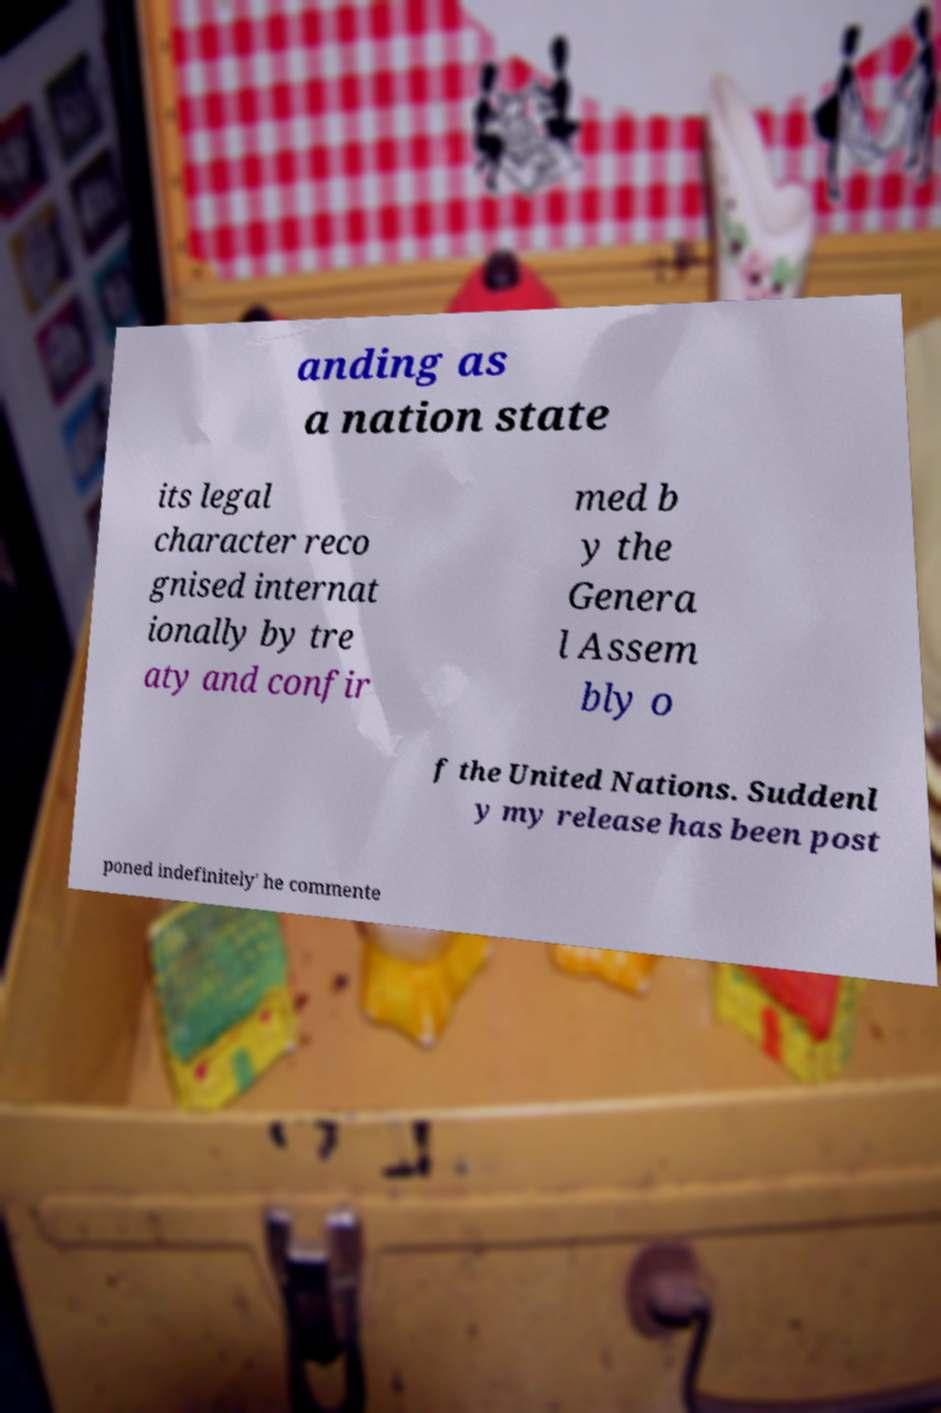Could you extract and type out the text from this image? anding as a nation state its legal character reco gnised internat ionally by tre aty and confir med b y the Genera l Assem bly o f the United Nations. Suddenl y my release has been post poned indefinitely' he commente 